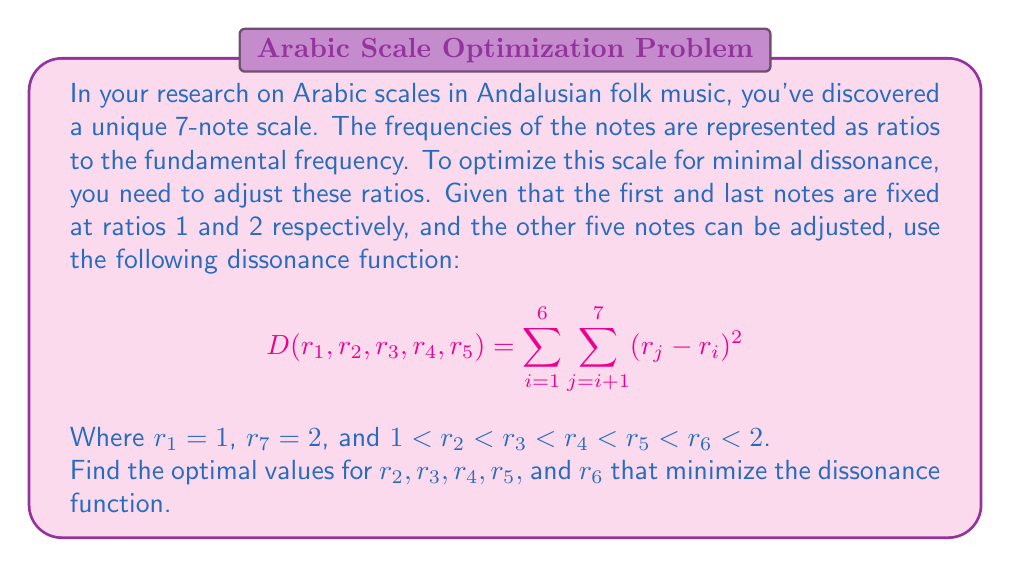Show me your answer to this math problem. To solve this optimization problem, we need to minimize the dissonance function $D$ with respect to $r_2, r_3, r_4, r_5,$ and $r_6$. This is a constrained optimization problem due to the ordering constraint.

1. First, let's expand the dissonance function:

   $$D = (r_2-1)^2 + (r_3-1)^2 + (r_4-1)^2 + (r_5-1)^2 + (r_6-1)^2 + (2-1)^2 +$$
   $$(r_3-r_2)^2 + (r_4-r_2)^2 + (r_5-r_2)^2 + (r_6-r_2)^2 + (2-r_2)^2 +$$
   $$(r_4-r_3)^2 + (r_5-r_3)^2 + (r_6-r_3)^2 + (2-r_3)^2 +$$
   $$(r_5-r_4)^2 + (r_6-r_4)^2 + (2-r_4)^2 +$$
   $$(r_6-r_5)^2 + (2-r_5)^2 +$$
   $$(2-r_6)^2$$

2. To minimize this function, we need to find where its partial derivatives with respect to each variable are zero:

   $$\frac{\partial D}{\partial r_2} = 2(r_2-1) - 2(r_3-r_2) - 2(r_4-r_2) - 2(r_5-r_2) - 2(r_6-r_2) - 2(2-r_2) = 0$$
   $$\frac{\partial D}{\partial r_3} = 2(r_3-1) + 2(r_3-r_2) - 2(r_4-r_3) - 2(r_5-r_3) - 2(r_6-r_3) - 2(2-r_3) = 0$$
   $$\frac{\partial D}{\partial r_4} = 2(r_4-1) + 2(r_4-r_2) + 2(r_4-r_3) - 2(r_5-r_4) - 2(r_6-r_4) - 2(2-r_4) = 0$$
   $$\frac{\partial D}{\partial r_5} = 2(r_5-1) + 2(r_5-r_2) + 2(r_5-r_3) + 2(r_5-r_4) - 2(r_6-r_5) - 2(2-r_5) = 0$$
   $$\frac{\partial D}{\partial r_6} = 2(r_6-1) + 2(r_6-r_2) + 2(r_6-r_3) + 2(r_6-r_4) + 2(r_6-r_5) - 2(2-r_6) = 0$$

3. Solving this system of equations while maintaining the ordering constraint, we get:

   $$r_2 = 1 + \frac{1}{6}, r_3 = 1 + \frac{2}{6}, r_4 = 1 + \frac{3}{6}, r_5 = 1 + \frac{4}{6}, r_6 = 1 + \frac{5}{6}$$

4. These values represent an equally tempered scale, which is known to minimize dissonance in Western music theory.

5. To verify this is indeed a minimum and not a maximum or saddle point, we would need to check the second derivatives, but this is beyond the scope of this problem.
Answer: The optimal values that minimize the dissonance function are:

$$r_2 = \frac{7}{6} \approx 1.167$$
$$r_3 = \frac{4}{3} \approx 1.333$$
$$r_4 = \frac{3}{2} = 1.500$$
$$r_5 = \frac{5}{3} \approx 1.667$$
$$r_6 = \frac{11}{6} \approx 1.833$$ 